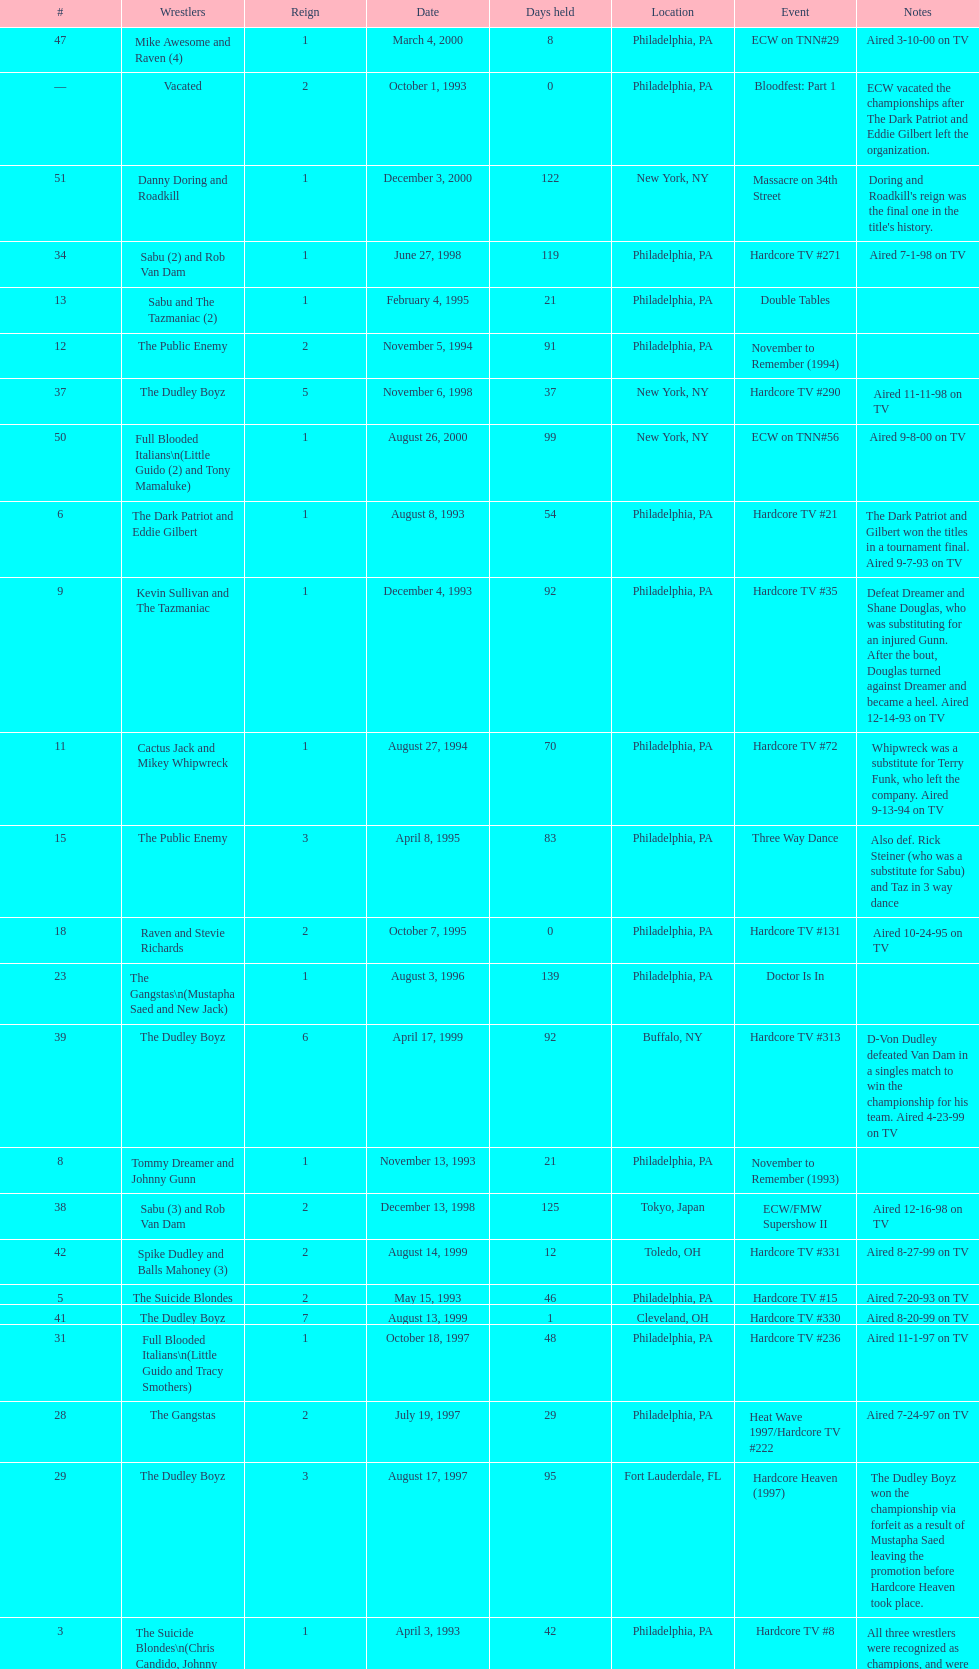How many days did hardcore tv #6 take? 1. 